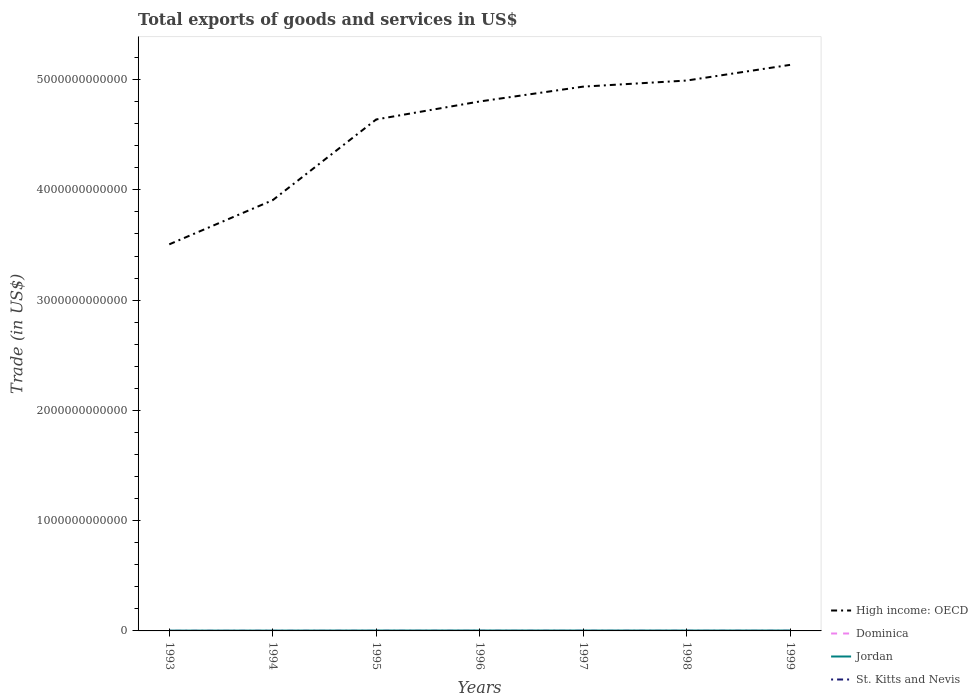Is the number of lines equal to the number of legend labels?
Your answer should be compact. Yes. Across all years, what is the maximum total exports of goods and services in Dominica?
Your answer should be compact. 9.73e+07. What is the total total exports of goods and services in High income: OECD in the graph?
Provide a short and direct response. -1.49e+12. What is the difference between the highest and the second highest total exports of goods and services in Dominica?
Ensure brevity in your answer.  5.95e+07. How many years are there in the graph?
Give a very brief answer. 7. What is the difference between two consecutive major ticks on the Y-axis?
Offer a terse response. 1.00e+12. How many legend labels are there?
Your answer should be compact. 4. How are the legend labels stacked?
Offer a terse response. Vertical. What is the title of the graph?
Your answer should be compact. Total exports of goods and services in US$. Does "Macao" appear as one of the legend labels in the graph?
Your response must be concise. No. What is the label or title of the Y-axis?
Ensure brevity in your answer.  Trade (in US$). What is the Trade (in US$) of High income: OECD in 1993?
Your answer should be very brief. 3.51e+12. What is the Trade (in US$) in Dominica in 1993?
Provide a short and direct response. 9.73e+07. What is the Trade (in US$) of Jordan in 1993?
Give a very brief answer. 2.82e+09. What is the Trade (in US$) in St. Kitts and Nevis in 1993?
Offer a very short reply. 1.15e+08. What is the Trade (in US$) of High income: OECD in 1994?
Provide a short and direct response. 3.91e+12. What is the Trade (in US$) of Dominica in 1994?
Provide a short and direct response. 1.06e+08. What is the Trade (in US$) of Jordan in 1994?
Make the answer very short. 2.98e+09. What is the Trade (in US$) in St. Kitts and Nevis in 1994?
Provide a succinct answer. 1.21e+08. What is the Trade (in US$) in High income: OECD in 1995?
Your response must be concise. 4.64e+12. What is the Trade (in US$) of Dominica in 1995?
Ensure brevity in your answer.  1.12e+08. What is the Trade (in US$) of Jordan in 1995?
Keep it short and to the point. 3.48e+09. What is the Trade (in US$) in St. Kitts and Nevis in 1995?
Your answer should be very brief. 1.19e+08. What is the Trade (in US$) in High income: OECD in 1996?
Provide a short and direct response. 4.80e+12. What is the Trade (in US$) in Dominica in 1996?
Give a very brief answer. 1.21e+08. What is the Trade (in US$) in Jordan in 1996?
Make the answer very short. 3.66e+09. What is the Trade (in US$) of St. Kitts and Nevis in 1996?
Give a very brief answer. 1.28e+08. What is the Trade (in US$) of High income: OECD in 1997?
Your answer should be very brief. 4.94e+12. What is the Trade (in US$) of Dominica in 1997?
Ensure brevity in your answer.  1.37e+08. What is the Trade (in US$) of Jordan in 1997?
Provide a short and direct response. 3.57e+09. What is the Trade (in US$) of St. Kitts and Nevis in 1997?
Offer a terse response. 1.40e+08. What is the Trade (in US$) in High income: OECD in 1998?
Provide a short and direct response. 4.99e+12. What is the Trade (in US$) of Dominica in 1998?
Your response must be concise. 1.52e+08. What is the Trade (in US$) in Jordan in 1998?
Offer a terse response. 3.55e+09. What is the Trade (in US$) of St. Kitts and Nevis in 1998?
Ensure brevity in your answer.  1.45e+08. What is the Trade (in US$) in High income: OECD in 1999?
Keep it short and to the point. 5.13e+12. What is the Trade (in US$) in Dominica in 1999?
Offer a terse response. 1.57e+08. What is the Trade (in US$) in Jordan in 1999?
Your answer should be compact. 3.53e+09. What is the Trade (in US$) of St. Kitts and Nevis in 1999?
Give a very brief answer. 1.46e+08. Across all years, what is the maximum Trade (in US$) of High income: OECD?
Provide a succinct answer. 5.13e+12. Across all years, what is the maximum Trade (in US$) in Dominica?
Your response must be concise. 1.57e+08. Across all years, what is the maximum Trade (in US$) in Jordan?
Offer a very short reply. 3.66e+09. Across all years, what is the maximum Trade (in US$) in St. Kitts and Nevis?
Offer a very short reply. 1.46e+08. Across all years, what is the minimum Trade (in US$) in High income: OECD?
Make the answer very short. 3.51e+12. Across all years, what is the minimum Trade (in US$) in Dominica?
Keep it short and to the point. 9.73e+07. Across all years, what is the minimum Trade (in US$) in Jordan?
Provide a short and direct response. 2.82e+09. Across all years, what is the minimum Trade (in US$) of St. Kitts and Nevis?
Your answer should be compact. 1.15e+08. What is the total Trade (in US$) of High income: OECD in the graph?
Ensure brevity in your answer.  3.19e+13. What is the total Trade (in US$) in Dominica in the graph?
Keep it short and to the point. 8.82e+08. What is the total Trade (in US$) in Jordan in the graph?
Offer a very short reply. 2.36e+1. What is the total Trade (in US$) in St. Kitts and Nevis in the graph?
Offer a terse response. 9.14e+08. What is the difference between the Trade (in US$) in High income: OECD in 1993 and that in 1994?
Make the answer very short. -4.01e+11. What is the difference between the Trade (in US$) of Dominica in 1993 and that in 1994?
Offer a very short reply. -8.37e+06. What is the difference between the Trade (in US$) in Jordan in 1993 and that in 1994?
Make the answer very short. -1.63e+08. What is the difference between the Trade (in US$) of St. Kitts and Nevis in 1993 and that in 1994?
Offer a terse response. -5.53e+06. What is the difference between the Trade (in US$) in High income: OECD in 1993 and that in 1995?
Your answer should be very brief. -1.13e+12. What is the difference between the Trade (in US$) in Dominica in 1993 and that in 1995?
Provide a succinct answer. -1.43e+07. What is the difference between the Trade (in US$) of Jordan in 1993 and that in 1995?
Ensure brevity in your answer.  -6.58e+08. What is the difference between the Trade (in US$) in St. Kitts and Nevis in 1993 and that in 1995?
Ensure brevity in your answer.  -3.09e+06. What is the difference between the Trade (in US$) of High income: OECD in 1993 and that in 1996?
Give a very brief answer. -1.30e+12. What is the difference between the Trade (in US$) in Dominica in 1993 and that in 1996?
Offer a terse response. -2.41e+07. What is the difference between the Trade (in US$) of Jordan in 1993 and that in 1996?
Your answer should be very brief. -8.41e+08. What is the difference between the Trade (in US$) in St. Kitts and Nevis in 1993 and that in 1996?
Make the answer very short. -1.22e+07. What is the difference between the Trade (in US$) of High income: OECD in 1993 and that in 1997?
Your response must be concise. -1.43e+12. What is the difference between the Trade (in US$) of Dominica in 1993 and that in 1997?
Your answer should be compact. -3.98e+07. What is the difference between the Trade (in US$) in Jordan in 1993 and that in 1997?
Provide a succinct answer. -7.50e+08. What is the difference between the Trade (in US$) of St. Kitts and Nevis in 1993 and that in 1997?
Offer a very short reply. -2.50e+07. What is the difference between the Trade (in US$) of High income: OECD in 1993 and that in 1998?
Give a very brief answer. -1.49e+12. What is the difference between the Trade (in US$) of Dominica in 1993 and that in 1998?
Make the answer very short. -5.43e+07. What is the difference between the Trade (in US$) in Jordan in 1993 and that in 1998?
Provide a short and direct response. -7.26e+08. What is the difference between the Trade (in US$) in St. Kitts and Nevis in 1993 and that in 1998?
Provide a short and direct response. -2.97e+07. What is the difference between the Trade (in US$) in High income: OECD in 1993 and that in 1999?
Offer a terse response. -1.63e+12. What is the difference between the Trade (in US$) in Dominica in 1993 and that in 1999?
Your response must be concise. -5.95e+07. What is the difference between the Trade (in US$) in Jordan in 1993 and that in 1999?
Your answer should be compact. -7.12e+08. What is the difference between the Trade (in US$) of St. Kitts and Nevis in 1993 and that in 1999?
Offer a terse response. -3.07e+07. What is the difference between the Trade (in US$) of High income: OECD in 1994 and that in 1995?
Provide a succinct answer. -7.32e+11. What is the difference between the Trade (in US$) of Dominica in 1994 and that in 1995?
Provide a succinct answer. -5.90e+06. What is the difference between the Trade (in US$) of Jordan in 1994 and that in 1995?
Your response must be concise. -4.95e+08. What is the difference between the Trade (in US$) in St. Kitts and Nevis in 1994 and that in 1995?
Your answer should be compact. 2.44e+06. What is the difference between the Trade (in US$) of High income: OECD in 1994 and that in 1996?
Ensure brevity in your answer.  -8.95e+11. What is the difference between the Trade (in US$) in Dominica in 1994 and that in 1996?
Your response must be concise. -1.57e+07. What is the difference between the Trade (in US$) in Jordan in 1994 and that in 1996?
Ensure brevity in your answer.  -6.78e+08. What is the difference between the Trade (in US$) of St. Kitts and Nevis in 1994 and that in 1996?
Make the answer very short. -6.67e+06. What is the difference between the Trade (in US$) of High income: OECD in 1994 and that in 1997?
Give a very brief answer. -1.03e+12. What is the difference between the Trade (in US$) of Dominica in 1994 and that in 1997?
Ensure brevity in your answer.  -3.14e+07. What is the difference between the Trade (in US$) of Jordan in 1994 and that in 1997?
Provide a short and direct response. -5.88e+08. What is the difference between the Trade (in US$) of St. Kitts and Nevis in 1994 and that in 1997?
Offer a very short reply. -1.94e+07. What is the difference between the Trade (in US$) of High income: OECD in 1994 and that in 1998?
Offer a very short reply. -1.08e+12. What is the difference between the Trade (in US$) in Dominica in 1994 and that in 1998?
Offer a terse response. -4.59e+07. What is the difference between the Trade (in US$) of Jordan in 1994 and that in 1998?
Keep it short and to the point. -5.63e+08. What is the difference between the Trade (in US$) of St. Kitts and Nevis in 1994 and that in 1998?
Your answer should be compact. -2.42e+07. What is the difference between the Trade (in US$) in High income: OECD in 1994 and that in 1999?
Offer a terse response. -1.23e+12. What is the difference between the Trade (in US$) of Dominica in 1994 and that in 1999?
Offer a terse response. -5.11e+07. What is the difference between the Trade (in US$) in Jordan in 1994 and that in 1999?
Provide a short and direct response. -5.49e+08. What is the difference between the Trade (in US$) of St. Kitts and Nevis in 1994 and that in 1999?
Provide a short and direct response. -2.52e+07. What is the difference between the Trade (in US$) of High income: OECD in 1995 and that in 1996?
Your response must be concise. -1.63e+11. What is the difference between the Trade (in US$) in Dominica in 1995 and that in 1996?
Your response must be concise. -9.80e+06. What is the difference between the Trade (in US$) of Jordan in 1995 and that in 1996?
Keep it short and to the point. -1.84e+08. What is the difference between the Trade (in US$) in St. Kitts and Nevis in 1995 and that in 1996?
Your answer should be compact. -9.11e+06. What is the difference between the Trade (in US$) in High income: OECD in 1995 and that in 1997?
Make the answer very short. -2.98e+11. What is the difference between the Trade (in US$) in Dominica in 1995 and that in 1997?
Your answer should be compact. -2.55e+07. What is the difference between the Trade (in US$) in Jordan in 1995 and that in 1997?
Your answer should be very brief. -9.28e+07. What is the difference between the Trade (in US$) in St. Kitts and Nevis in 1995 and that in 1997?
Your response must be concise. -2.19e+07. What is the difference between the Trade (in US$) of High income: OECD in 1995 and that in 1998?
Ensure brevity in your answer.  -3.53e+11. What is the difference between the Trade (in US$) of Dominica in 1995 and that in 1998?
Your answer should be very brief. -4.00e+07. What is the difference between the Trade (in US$) in Jordan in 1995 and that in 1998?
Keep it short and to the point. -6.86e+07. What is the difference between the Trade (in US$) in St. Kitts and Nevis in 1995 and that in 1998?
Offer a very short reply. -2.66e+07. What is the difference between the Trade (in US$) of High income: OECD in 1995 and that in 1999?
Provide a short and direct response. -4.95e+11. What is the difference between the Trade (in US$) of Dominica in 1995 and that in 1999?
Your answer should be very brief. -4.52e+07. What is the difference between the Trade (in US$) of Jordan in 1995 and that in 1999?
Your answer should be very brief. -5.41e+07. What is the difference between the Trade (in US$) of St. Kitts and Nevis in 1995 and that in 1999?
Give a very brief answer. -2.77e+07. What is the difference between the Trade (in US$) of High income: OECD in 1996 and that in 1997?
Offer a very short reply. -1.35e+11. What is the difference between the Trade (in US$) in Dominica in 1996 and that in 1997?
Offer a terse response. -1.57e+07. What is the difference between the Trade (in US$) of Jordan in 1996 and that in 1997?
Make the answer very short. 9.08e+07. What is the difference between the Trade (in US$) of St. Kitts and Nevis in 1996 and that in 1997?
Provide a succinct answer. -1.28e+07. What is the difference between the Trade (in US$) in High income: OECD in 1996 and that in 1998?
Provide a short and direct response. -1.90e+11. What is the difference between the Trade (in US$) in Dominica in 1996 and that in 1998?
Provide a succinct answer. -3.02e+07. What is the difference between the Trade (in US$) in Jordan in 1996 and that in 1998?
Provide a short and direct response. 1.15e+08. What is the difference between the Trade (in US$) in St. Kitts and Nevis in 1996 and that in 1998?
Offer a terse response. -1.75e+07. What is the difference between the Trade (in US$) in High income: OECD in 1996 and that in 1999?
Keep it short and to the point. -3.32e+11. What is the difference between the Trade (in US$) in Dominica in 1996 and that in 1999?
Offer a terse response. -3.54e+07. What is the difference between the Trade (in US$) of Jordan in 1996 and that in 1999?
Your answer should be very brief. 1.29e+08. What is the difference between the Trade (in US$) in St. Kitts and Nevis in 1996 and that in 1999?
Ensure brevity in your answer.  -1.85e+07. What is the difference between the Trade (in US$) in High income: OECD in 1997 and that in 1998?
Your answer should be compact. -5.52e+1. What is the difference between the Trade (in US$) of Dominica in 1997 and that in 1998?
Offer a terse response. -1.45e+07. What is the difference between the Trade (in US$) of Jordan in 1997 and that in 1998?
Your answer should be very brief. 2.41e+07. What is the difference between the Trade (in US$) of St. Kitts and Nevis in 1997 and that in 1998?
Give a very brief answer. -4.75e+06. What is the difference between the Trade (in US$) of High income: OECD in 1997 and that in 1999?
Provide a short and direct response. -1.97e+11. What is the difference between the Trade (in US$) of Dominica in 1997 and that in 1999?
Provide a short and direct response. -1.97e+07. What is the difference between the Trade (in US$) in Jordan in 1997 and that in 1999?
Offer a very short reply. 3.86e+07. What is the difference between the Trade (in US$) in St. Kitts and Nevis in 1997 and that in 1999?
Ensure brevity in your answer.  -5.78e+06. What is the difference between the Trade (in US$) in High income: OECD in 1998 and that in 1999?
Offer a terse response. -1.42e+11. What is the difference between the Trade (in US$) in Dominica in 1998 and that in 1999?
Offer a terse response. -5.21e+06. What is the difference between the Trade (in US$) of Jordan in 1998 and that in 1999?
Make the answer very short. 1.45e+07. What is the difference between the Trade (in US$) of St. Kitts and Nevis in 1998 and that in 1999?
Provide a succinct answer. -1.04e+06. What is the difference between the Trade (in US$) of High income: OECD in 1993 and the Trade (in US$) of Dominica in 1994?
Your response must be concise. 3.51e+12. What is the difference between the Trade (in US$) in High income: OECD in 1993 and the Trade (in US$) in Jordan in 1994?
Make the answer very short. 3.50e+12. What is the difference between the Trade (in US$) of High income: OECD in 1993 and the Trade (in US$) of St. Kitts and Nevis in 1994?
Offer a very short reply. 3.51e+12. What is the difference between the Trade (in US$) of Dominica in 1993 and the Trade (in US$) of Jordan in 1994?
Your answer should be very brief. -2.89e+09. What is the difference between the Trade (in US$) in Dominica in 1993 and the Trade (in US$) in St. Kitts and Nevis in 1994?
Make the answer very short. -2.36e+07. What is the difference between the Trade (in US$) in Jordan in 1993 and the Trade (in US$) in St. Kitts and Nevis in 1994?
Offer a terse response. 2.70e+09. What is the difference between the Trade (in US$) of High income: OECD in 1993 and the Trade (in US$) of Dominica in 1995?
Your answer should be very brief. 3.51e+12. What is the difference between the Trade (in US$) in High income: OECD in 1993 and the Trade (in US$) in Jordan in 1995?
Provide a short and direct response. 3.50e+12. What is the difference between the Trade (in US$) in High income: OECD in 1993 and the Trade (in US$) in St. Kitts and Nevis in 1995?
Give a very brief answer. 3.51e+12. What is the difference between the Trade (in US$) in Dominica in 1993 and the Trade (in US$) in Jordan in 1995?
Your answer should be very brief. -3.38e+09. What is the difference between the Trade (in US$) of Dominica in 1993 and the Trade (in US$) of St. Kitts and Nevis in 1995?
Ensure brevity in your answer.  -2.12e+07. What is the difference between the Trade (in US$) of Jordan in 1993 and the Trade (in US$) of St. Kitts and Nevis in 1995?
Make the answer very short. 2.70e+09. What is the difference between the Trade (in US$) in High income: OECD in 1993 and the Trade (in US$) in Dominica in 1996?
Offer a very short reply. 3.51e+12. What is the difference between the Trade (in US$) of High income: OECD in 1993 and the Trade (in US$) of Jordan in 1996?
Provide a succinct answer. 3.50e+12. What is the difference between the Trade (in US$) of High income: OECD in 1993 and the Trade (in US$) of St. Kitts and Nevis in 1996?
Offer a terse response. 3.51e+12. What is the difference between the Trade (in US$) in Dominica in 1993 and the Trade (in US$) in Jordan in 1996?
Offer a very short reply. -3.57e+09. What is the difference between the Trade (in US$) of Dominica in 1993 and the Trade (in US$) of St. Kitts and Nevis in 1996?
Keep it short and to the point. -3.03e+07. What is the difference between the Trade (in US$) of Jordan in 1993 and the Trade (in US$) of St. Kitts and Nevis in 1996?
Provide a short and direct response. 2.69e+09. What is the difference between the Trade (in US$) of High income: OECD in 1993 and the Trade (in US$) of Dominica in 1997?
Your response must be concise. 3.51e+12. What is the difference between the Trade (in US$) of High income: OECD in 1993 and the Trade (in US$) of Jordan in 1997?
Make the answer very short. 3.50e+12. What is the difference between the Trade (in US$) of High income: OECD in 1993 and the Trade (in US$) of St. Kitts and Nevis in 1997?
Offer a very short reply. 3.51e+12. What is the difference between the Trade (in US$) of Dominica in 1993 and the Trade (in US$) of Jordan in 1997?
Offer a terse response. -3.48e+09. What is the difference between the Trade (in US$) in Dominica in 1993 and the Trade (in US$) in St. Kitts and Nevis in 1997?
Provide a succinct answer. -4.31e+07. What is the difference between the Trade (in US$) in Jordan in 1993 and the Trade (in US$) in St. Kitts and Nevis in 1997?
Your response must be concise. 2.68e+09. What is the difference between the Trade (in US$) in High income: OECD in 1993 and the Trade (in US$) in Dominica in 1998?
Your answer should be very brief. 3.51e+12. What is the difference between the Trade (in US$) of High income: OECD in 1993 and the Trade (in US$) of Jordan in 1998?
Make the answer very short. 3.50e+12. What is the difference between the Trade (in US$) in High income: OECD in 1993 and the Trade (in US$) in St. Kitts and Nevis in 1998?
Provide a succinct answer. 3.51e+12. What is the difference between the Trade (in US$) of Dominica in 1993 and the Trade (in US$) of Jordan in 1998?
Keep it short and to the point. -3.45e+09. What is the difference between the Trade (in US$) of Dominica in 1993 and the Trade (in US$) of St. Kitts and Nevis in 1998?
Your answer should be very brief. -4.78e+07. What is the difference between the Trade (in US$) of Jordan in 1993 and the Trade (in US$) of St. Kitts and Nevis in 1998?
Your response must be concise. 2.68e+09. What is the difference between the Trade (in US$) in High income: OECD in 1993 and the Trade (in US$) in Dominica in 1999?
Your answer should be very brief. 3.51e+12. What is the difference between the Trade (in US$) of High income: OECD in 1993 and the Trade (in US$) of Jordan in 1999?
Offer a terse response. 3.50e+12. What is the difference between the Trade (in US$) in High income: OECD in 1993 and the Trade (in US$) in St. Kitts and Nevis in 1999?
Give a very brief answer. 3.51e+12. What is the difference between the Trade (in US$) of Dominica in 1993 and the Trade (in US$) of Jordan in 1999?
Make the answer very short. -3.44e+09. What is the difference between the Trade (in US$) in Dominica in 1993 and the Trade (in US$) in St. Kitts and Nevis in 1999?
Make the answer very short. -4.88e+07. What is the difference between the Trade (in US$) in Jordan in 1993 and the Trade (in US$) in St. Kitts and Nevis in 1999?
Provide a short and direct response. 2.68e+09. What is the difference between the Trade (in US$) in High income: OECD in 1994 and the Trade (in US$) in Dominica in 1995?
Provide a succinct answer. 3.91e+12. What is the difference between the Trade (in US$) of High income: OECD in 1994 and the Trade (in US$) of Jordan in 1995?
Offer a very short reply. 3.90e+12. What is the difference between the Trade (in US$) in High income: OECD in 1994 and the Trade (in US$) in St. Kitts and Nevis in 1995?
Offer a very short reply. 3.91e+12. What is the difference between the Trade (in US$) of Dominica in 1994 and the Trade (in US$) of Jordan in 1995?
Make the answer very short. -3.37e+09. What is the difference between the Trade (in US$) in Dominica in 1994 and the Trade (in US$) in St. Kitts and Nevis in 1995?
Provide a succinct answer. -1.28e+07. What is the difference between the Trade (in US$) of Jordan in 1994 and the Trade (in US$) of St. Kitts and Nevis in 1995?
Keep it short and to the point. 2.87e+09. What is the difference between the Trade (in US$) in High income: OECD in 1994 and the Trade (in US$) in Dominica in 1996?
Your answer should be very brief. 3.91e+12. What is the difference between the Trade (in US$) in High income: OECD in 1994 and the Trade (in US$) in Jordan in 1996?
Offer a very short reply. 3.90e+12. What is the difference between the Trade (in US$) of High income: OECD in 1994 and the Trade (in US$) of St. Kitts and Nevis in 1996?
Provide a succinct answer. 3.91e+12. What is the difference between the Trade (in US$) of Dominica in 1994 and the Trade (in US$) of Jordan in 1996?
Your answer should be compact. -3.56e+09. What is the difference between the Trade (in US$) of Dominica in 1994 and the Trade (in US$) of St. Kitts and Nevis in 1996?
Ensure brevity in your answer.  -2.19e+07. What is the difference between the Trade (in US$) of Jordan in 1994 and the Trade (in US$) of St. Kitts and Nevis in 1996?
Keep it short and to the point. 2.86e+09. What is the difference between the Trade (in US$) of High income: OECD in 1994 and the Trade (in US$) of Dominica in 1997?
Provide a succinct answer. 3.91e+12. What is the difference between the Trade (in US$) of High income: OECD in 1994 and the Trade (in US$) of Jordan in 1997?
Make the answer very short. 3.90e+12. What is the difference between the Trade (in US$) in High income: OECD in 1994 and the Trade (in US$) in St. Kitts and Nevis in 1997?
Give a very brief answer. 3.91e+12. What is the difference between the Trade (in US$) in Dominica in 1994 and the Trade (in US$) in Jordan in 1997?
Your answer should be very brief. -3.47e+09. What is the difference between the Trade (in US$) of Dominica in 1994 and the Trade (in US$) of St. Kitts and Nevis in 1997?
Your answer should be compact. -3.47e+07. What is the difference between the Trade (in US$) in Jordan in 1994 and the Trade (in US$) in St. Kitts and Nevis in 1997?
Ensure brevity in your answer.  2.84e+09. What is the difference between the Trade (in US$) of High income: OECD in 1994 and the Trade (in US$) of Dominica in 1998?
Provide a succinct answer. 3.91e+12. What is the difference between the Trade (in US$) of High income: OECD in 1994 and the Trade (in US$) of Jordan in 1998?
Provide a short and direct response. 3.90e+12. What is the difference between the Trade (in US$) in High income: OECD in 1994 and the Trade (in US$) in St. Kitts and Nevis in 1998?
Provide a short and direct response. 3.91e+12. What is the difference between the Trade (in US$) in Dominica in 1994 and the Trade (in US$) in Jordan in 1998?
Ensure brevity in your answer.  -3.44e+09. What is the difference between the Trade (in US$) of Dominica in 1994 and the Trade (in US$) of St. Kitts and Nevis in 1998?
Provide a succinct answer. -3.94e+07. What is the difference between the Trade (in US$) of Jordan in 1994 and the Trade (in US$) of St. Kitts and Nevis in 1998?
Give a very brief answer. 2.84e+09. What is the difference between the Trade (in US$) of High income: OECD in 1994 and the Trade (in US$) of Dominica in 1999?
Your answer should be compact. 3.91e+12. What is the difference between the Trade (in US$) in High income: OECD in 1994 and the Trade (in US$) in Jordan in 1999?
Give a very brief answer. 3.90e+12. What is the difference between the Trade (in US$) of High income: OECD in 1994 and the Trade (in US$) of St. Kitts and Nevis in 1999?
Offer a very short reply. 3.91e+12. What is the difference between the Trade (in US$) in Dominica in 1994 and the Trade (in US$) in Jordan in 1999?
Give a very brief answer. -3.43e+09. What is the difference between the Trade (in US$) in Dominica in 1994 and the Trade (in US$) in St. Kitts and Nevis in 1999?
Keep it short and to the point. -4.05e+07. What is the difference between the Trade (in US$) of Jordan in 1994 and the Trade (in US$) of St. Kitts and Nevis in 1999?
Your answer should be compact. 2.84e+09. What is the difference between the Trade (in US$) in High income: OECD in 1995 and the Trade (in US$) in Dominica in 1996?
Offer a very short reply. 4.64e+12. What is the difference between the Trade (in US$) of High income: OECD in 1995 and the Trade (in US$) of Jordan in 1996?
Give a very brief answer. 4.64e+12. What is the difference between the Trade (in US$) in High income: OECD in 1995 and the Trade (in US$) in St. Kitts and Nevis in 1996?
Offer a terse response. 4.64e+12. What is the difference between the Trade (in US$) of Dominica in 1995 and the Trade (in US$) of Jordan in 1996?
Offer a very short reply. -3.55e+09. What is the difference between the Trade (in US$) in Dominica in 1995 and the Trade (in US$) in St. Kitts and Nevis in 1996?
Your answer should be very brief. -1.60e+07. What is the difference between the Trade (in US$) in Jordan in 1995 and the Trade (in US$) in St. Kitts and Nevis in 1996?
Make the answer very short. 3.35e+09. What is the difference between the Trade (in US$) of High income: OECD in 1995 and the Trade (in US$) of Dominica in 1997?
Give a very brief answer. 4.64e+12. What is the difference between the Trade (in US$) of High income: OECD in 1995 and the Trade (in US$) of Jordan in 1997?
Keep it short and to the point. 4.64e+12. What is the difference between the Trade (in US$) in High income: OECD in 1995 and the Trade (in US$) in St. Kitts and Nevis in 1997?
Give a very brief answer. 4.64e+12. What is the difference between the Trade (in US$) of Dominica in 1995 and the Trade (in US$) of Jordan in 1997?
Give a very brief answer. -3.46e+09. What is the difference between the Trade (in US$) in Dominica in 1995 and the Trade (in US$) in St. Kitts and Nevis in 1997?
Give a very brief answer. -2.88e+07. What is the difference between the Trade (in US$) in Jordan in 1995 and the Trade (in US$) in St. Kitts and Nevis in 1997?
Offer a terse response. 3.34e+09. What is the difference between the Trade (in US$) of High income: OECD in 1995 and the Trade (in US$) of Dominica in 1998?
Offer a very short reply. 4.64e+12. What is the difference between the Trade (in US$) of High income: OECD in 1995 and the Trade (in US$) of Jordan in 1998?
Provide a succinct answer. 4.64e+12. What is the difference between the Trade (in US$) in High income: OECD in 1995 and the Trade (in US$) in St. Kitts and Nevis in 1998?
Offer a terse response. 4.64e+12. What is the difference between the Trade (in US$) in Dominica in 1995 and the Trade (in US$) in Jordan in 1998?
Offer a terse response. -3.44e+09. What is the difference between the Trade (in US$) of Dominica in 1995 and the Trade (in US$) of St. Kitts and Nevis in 1998?
Give a very brief answer. -3.35e+07. What is the difference between the Trade (in US$) of Jordan in 1995 and the Trade (in US$) of St. Kitts and Nevis in 1998?
Your answer should be very brief. 3.33e+09. What is the difference between the Trade (in US$) in High income: OECD in 1995 and the Trade (in US$) in Dominica in 1999?
Offer a terse response. 4.64e+12. What is the difference between the Trade (in US$) of High income: OECD in 1995 and the Trade (in US$) of Jordan in 1999?
Keep it short and to the point. 4.64e+12. What is the difference between the Trade (in US$) in High income: OECD in 1995 and the Trade (in US$) in St. Kitts and Nevis in 1999?
Make the answer very short. 4.64e+12. What is the difference between the Trade (in US$) of Dominica in 1995 and the Trade (in US$) of Jordan in 1999?
Your answer should be compact. -3.42e+09. What is the difference between the Trade (in US$) of Dominica in 1995 and the Trade (in US$) of St. Kitts and Nevis in 1999?
Keep it short and to the point. -3.46e+07. What is the difference between the Trade (in US$) of Jordan in 1995 and the Trade (in US$) of St. Kitts and Nevis in 1999?
Provide a short and direct response. 3.33e+09. What is the difference between the Trade (in US$) of High income: OECD in 1996 and the Trade (in US$) of Dominica in 1997?
Your answer should be compact. 4.80e+12. What is the difference between the Trade (in US$) in High income: OECD in 1996 and the Trade (in US$) in Jordan in 1997?
Keep it short and to the point. 4.80e+12. What is the difference between the Trade (in US$) in High income: OECD in 1996 and the Trade (in US$) in St. Kitts and Nevis in 1997?
Your answer should be very brief. 4.80e+12. What is the difference between the Trade (in US$) in Dominica in 1996 and the Trade (in US$) in Jordan in 1997?
Offer a very short reply. -3.45e+09. What is the difference between the Trade (in US$) in Dominica in 1996 and the Trade (in US$) in St. Kitts and Nevis in 1997?
Provide a short and direct response. -1.90e+07. What is the difference between the Trade (in US$) in Jordan in 1996 and the Trade (in US$) in St. Kitts and Nevis in 1997?
Your answer should be compact. 3.52e+09. What is the difference between the Trade (in US$) in High income: OECD in 1996 and the Trade (in US$) in Dominica in 1998?
Offer a terse response. 4.80e+12. What is the difference between the Trade (in US$) in High income: OECD in 1996 and the Trade (in US$) in Jordan in 1998?
Keep it short and to the point. 4.80e+12. What is the difference between the Trade (in US$) in High income: OECD in 1996 and the Trade (in US$) in St. Kitts and Nevis in 1998?
Ensure brevity in your answer.  4.80e+12. What is the difference between the Trade (in US$) in Dominica in 1996 and the Trade (in US$) in Jordan in 1998?
Provide a succinct answer. -3.43e+09. What is the difference between the Trade (in US$) in Dominica in 1996 and the Trade (in US$) in St. Kitts and Nevis in 1998?
Ensure brevity in your answer.  -2.37e+07. What is the difference between the Trade (in US$) in Jordan in 1996 and the Trade (in US$) in St. Kitts and Nevis in 1998?
Your response must be concise. 3.52e+09. What is the difference between the Trade (in US$) in High income: OECD in 1996 and the Trade (in US$) in Dominica in 1999?
Your answer should be very brief. 4.80e+12. What is the difference between the Trade (in US$) of High income: OECD in 1996 and the Trade (in US$) of Jordan in 1999?
Offer a terse response. 4.80e+12. What is the difference between the Trade (in US$) in High income: OECD in 1996 and the Trade (in US$) in St. Kitts and Nevis in 1999?
Keep it short and to the point. 4.80e+12. What is the difference between the Trade (in US$) of Dominica in 1996 and the Trade (in US$) of Jordan in 1999?
Offer a very short reply. -3.41e+09. What is the difference between the Trade (in US$) of Dominica in 1996 and the Trade (in US$) of St. Kitts and Nevis in 1999?
Your response must be concise. -2.48e+07. What is the difference between the Trade (in US$) in Jordan in 1996 and the Trade (in US$) in St. Kitts and Nevis in 1999?
Make the answer very short. 3.52e+09. What is the difference between the Trade (in US$) in High income: OECD in 1997 and the Trade (in US$) in Dominica in 1998?
Offer a terse response. 4.94e+12. What is the difference between the Trade (in US$) of High income: OECD in 1997 and the Trade (in US$) of Jordan in 1998?
Ensure brevity in your answer.  4.93e+12. What is the difference between the Trade (in US$) in High income: OECD in 1997 and the Trade (in US$) in St. Kitts and Nevis in 1998?
Your answer should be compact. 4.94e+12. What is the difference between the Trade (in US$) in Dominica in 1997 and the Trade (in US$) in Jordan in 1998?
Keep it short and to the point. -3.41e+09. What is the difference between the Trade (in US$) of Dominica in 1997 and the Trade (in US$) of St. Kitts and Nevis in 1998?
Ensure brevity in your answer.  -7.98e+06. What is the difference between the Trade (in US$) in Jordan in 1997 and the Trade (in US$) in St. Kitts and Nevis in 1998?
Give a very brief answer. 3.43e+09. What is the difference between the Trade (in US$) in High income: OECD in 1997 and the Trade (in US$) in Dominica in 1999?
Your answer should be very brief. 4.94e+12. What is the difference between the Trade (in US$) in High income: OECD in 1997 and the Trade (in US$) in Jordan in 1999?
Keep it short and to the point. 4.93e+12. What is the difference between the Trade (in US$) in High income: OECD in 1997 and the Trade (in US$) in St. Kitts and Nevis in 1999?
Ensure brevity in your answer.  4.94e+12. What is the difference between the Trade (in US$) of Dominica in 1997 and the Trade (in US$) of Jordan in 1999?
Provide a succinct answer. -3.40e+09. What is the difference between the Trade (in US$) of Dominica in 1997 and the Trade (in US$) of St. Kitts and Nevis in 1999?
Keep it short and to the point. -9.02e+06. What is the difference between the Trade (in US$) of Jordan in 1997 and the Trade (in US$) of St. Kitts and Nevis in 1999?
Provide a short and direct response. 3.43e+09. What is the difference between the Trade (in US$) in High income: OECD in 1998 and the Trade (in US$) in Dominica in 1999?
Ensure brevity in your answer.  4.99e+12. What is the difference between the Trade (in US$) in High income: OECD in 1998 and the Trade (in US$) in Jordan in 1999?
Your answer should be very brief. 4.99e+12. What is the difference between the Trade (in US$) in High income: OECD in 1998 and the Trade (in US$) in St. Kitts and Nevis in 1999?
Provide a succinct answer. 4.99e+12. What is the difference between the Trade (in US$) in Dominica in 1998 and the Trade (in US$) in Jordan in 1999?
Keep it short and to the point. -3.38e+09. What is the difference between the Trade (in US$) in Dominica in 1998 and the Trade (in US$) in St. Kitts and Nevis in 1999?
Ensure brevity in your answer.  5.44e+06. What is the difference between the Trade (in US$) in Jordan in 1998 and the Trade (in US$) in St. Kitts and Nevis in 1999?
Your answer should be very brief. 3.40e+09. What is the average Trade (in US$) of High income: OECD per year?
Make the answer very short. 4.56e+12. What is the average Trade (in US$) of Dominica per year?
Offer a terse response. 1.26e+08. What is the average Trade (in US$) in Jordan per year?
Give a very brief answer. 3.37e+09. What is the average Trade (in US$) in St. Kitts and Nevis per year?
Offer a very short reply. 1.31e+08. In the year 1993, what is the difference between the Trade (in US$) of High income: OECD and Trade (in US$) of Dominica?
Give a very brief answer. 3.51e+12. In the year 1993, what is the difference between the Trade (in US$) of High income: OECD and Trade (in US$) of Jordan?
Keep it short and to the point. 3.50e+12. In the year 1993, what is the difference between the Trade (in US$) in High income: OECD and Trade (in US$) in St. Kitts and Nevis?
Provide a succinct answer. 3.51e+12. In the year 1993, what is the difference between the Trade (in US$) of Dominica and Trade (in US$) of Jordan?
Give a very brief answer. -2.72e+09. In the year 1993, what is the difference between the Trade (in US$) in Dominica and Trade (in US$) in St. Kitts and Nevis?
Make the answer very short. -1.81e+07. In the year 1993, what is the difference between the Trade (in US$) of Jordan and Trade (in US$) of St. Kitts and Nevis?
Make the answer very short. 2.71e+09. In the year 1994, what is the difference between the Trade (in US$) in High income: OECD and Trade (in US$) in Dominica?
Your response must be concise. 3.91e+12. In the year 1994, what is the difference between the Trade (in US$) of High income: OECD and Trade (in US$) of Jordan?
Offer a terse response. 3.90e+12. In the year 1994, what is the difference between the Trade (in US$) of High income: OECD and Trade (in US$) of St. Kitts and Nevis?
Offer a very short reply. 3.91e+12. In the year 1994, what is the difference between the Trade (in US$) of Dominica and Trade (in US$) of Jordan?
Provide a short and direct response. -2.88e+09. In the year 1994, what is the difference between the Trade (in US$) of Dominica and Trade (in US$) of St. Kitts and Nevis?
Your response must be concise. -1.52e+07. In the year 1994, what is the difference between the Trade (in US$) of Jordan and Trade (in US$) of St. Kitts and Nevis?
Your answer should be compact. 2.86e+09. In the year 1995, what is the difference between the Trade (in US$) in High income: OECD and Trade (in US$) in Dominica?
Keep it short and to the point. 4.64e+12. In the year 1995, what is the difference between the Trade (in US$) of High income: OECD and Trade (in US$) of Jordan?
Your answer should be very brief. 4.64e+12. In the year 1995, what is the difference between the Trade (in US$) of High income: OECD and Trade (in US$) of St. Kitts and Nevis?
Keep it short and to the point. 4.64e+12. In the year 1995, what is the difference between the Trade (in US$) in Dominica and Trade (in US$) in Jordan?
Provide a short and direct response. -3.37e+09. In the year 1995, what is the difference between the Trade (in US$) of Dominica and Trade (in US$) of St. Kitts and Nevis?
Give a very brief answer. -6.91e+06. In the year 1995, what is the difference between the Trade (in US$) of Jordan and Trade (in US$) of St. Kitts and Nevis?
Offer a very short reply. 3.36e+09. In the year 1996, what is the difference between the Trade (in US$) of High income: OECD and Trade (in US$) of Dominica?
Offer a very short reply. 4.80e+12. In the year 1996, what is the difference between the Trade (in US$) of High income: OECD and Trade (in US$) of Jordan?
Provide a short and direct response. 4.80e+12. In the year 1996, what is the difference between the Trade (in US$) in High income: OECD and Trade (in US$) in St. Kitts and Nevis?
Offer a terse response. 4.80e+12. In the year 1996, what is the difference between the Trade (in US$) in Dominica and Trade (in US$) in Jordan?
Your answer should be compact. -3.54e+09. In the year 1996, what is the difference between the Trade (in US$) in Dominica and Trade (in US$) in St. Kitts and Nevis?
Keep it short and to the point. -6.22e+06. In the year 1996, what is the difference between the Trade (in US$) in Jordan and Trade (in US$) in St. Kitts and Nevis?
Provide a succinct answer. 3.54e+09. In the year 1997, what is the difference between the Trade (in US$) of High income: OECD and Trade (in US$) of Dominica?
Provide a succinct answer. 4.94e+12. In the year 1997, what is the difference between the Trade (in US$) in High income: OECD and Trade (in US$) in Jordan?
Give a very brief answer. 4.93e+12. In the year 1997, what is the difference between the Trade (in US$) of High income: OECD and Trade (in US$) of St. Kitts and Nevis?
Make the answer very short. 4.94e+12. In the year 1997, what is the difference between the Trade (in US$) of Dominica and Trade (in US$) of Jordan?
Ensure brevity in your answer.  -3.44e+09. In the year 1997, what is the difference between the Trade (in US$) in Dominica and Trade (in US$) in St. Kitts and Nevis?
Give a very brief answer. -3.23e+06. In the year 1997, what is the difference between the Trade (in US$) of Jordan and Trade (in US$) of St. Kitts and Nevis?
Keep it short and to the point. 3.43e+09. In the year 1998, what is the difference between the Trade (in US$) in High income: OECD and Trade (in US$) in Dominica?
Ensure brevity in your answer.  4.99e+12. In the year 1998, what is the difference between the Trade (in US$) of High income: OECD and Trade (in US$) of Jordan?
Your response must be concise. 4.99e+12. In the year 1998, what is the difference between the Trade (in US$) in High income: OECD and Trade (in US$) in St. Kitts and Nevis?
Ensure brevity in your answer.  4.99e+12. In the year 1998, what is the difference between the Trade (in US$) of Dominica and Trade (in US$) of Jordan?
Make the answer very short. -3.40e+09. In the year 1998, what is the difference between the Trade (in US$) of Dominica and Trade (in US$) of St. Kitts and Nevis?
Ensure brevity in your answer.  6.48e+06. In the year 1998, what is the difference between the Trade (in US$) in Jordan and Trade (in US$) in St. Kitts and Nevis?
Provide a short and direct response. 3.40e+09. In the year 1999, what is the difference between the Trade (in US$) of High income: OECD and Trade (in US$) of Dominica?
Make the answer very short. 5.13e+12. In the year 1999, what is the difference between the Trade (in US$) in High income: OECD and Trade (in US$) in Jordan?
Offer a very short reply. 5.13e+12. In the year 1999, what is the difference between the Trade (in US$) in High income: OECD and Trade (in US$) in St. Kitts and Nevis?
Your answer should be compact. 5.13e+12. In the year 1999, what is the difference between the Trade (in US$) of Dominica and Trade (in US$) of Jordan?
Provide a short and direct response. -3.38e+09. In the year 1999, what is the difference between the Trade (in US$) in Dominica and Trade (in US$) in St. Kitts and Nevis?
Provide a succinct answer. 1.07e+07. In the year 1999, what is the difference between the Trade (in US$) of Jordan and Trade (in US$) of St. Kitts and Nevis?
Keep it short and to the point. 3.39e+09. What is the ratio of the Trade (in US$) of High income: OECD in 1993 to that in 1994?
Give a very brief answer. 0.9. What is the ratio of the Trade (in US$) of Dominica in 1993 to that in 1994?
Ensure brevity in your answer.  0.92. What is the ratio of the Trade (in US$) of Jordan in 1993 to that in 1994?
Give a very brief answer. 0.95. What is the ratio of the Trade (in US$) in St. Kitts and Nevis in 1993 to that in 1994?
Make the answer very short. 0.95. What is the ratio of the Trade (in US$) of High income: OECD in 1993 to that in 1995?
Your response must be concise. 0.76. What is the ratio of the Trade (in US$) in Dominica in 1993 to that in 1995?
Provide a succinct answer. 0.87. What is the ratio of the Trade (in US$) of Jordan in 1993 to that in 1995?
Offer a very short reply. 0.81. What is the ratio of the Trade (in US$) in St. Kitts and Nevis in 1993 to that in 1995?
Your answer should be very brief. 0.97. What is the ratio of the Trade (in US$) in High income: OECD in 1993 to that in 1996?
Give a very brief answer. 0.73. What is the ratio of the Trade (in US$) in Dominica in 1993 to that in 1996?
Your answer should be very brief. 0.8. What is the ratio of the Trade (in US$) in Jordan in 1993 to that in 1996?
Your answer should be very brief. 0.77. What is the ratio of the Trade (in US$) of St. Kitts and Nevis in 1993 to that in 1996?
Your answer should be compact. 0.9. What is the ratio of the Trade (in US$) of High income: OECD in 1993 to that in 1997?
Offer a very short reply. 0.71. What is the ratio of the Trade (in US$) in Dominica in 1993 to that in 1997?
Offer a terse response. 0.71. What is the ratio of the Trade (in US$) in Jordan in 1993 to that in 1997?
Your answer should be very brief. 0.79. What is the ratio of the Trade (in US$) in St. Kitts and Nevis in 1993 to that in 1997?
Offer a very short reply. 0.82. What is the ratio of the Trade (in US$) in High income: OECD in 1993 to that in 1998?
Your response must be concise. 0.7. What is the ratio of the Trade (in US$) of Dominica in 1993 to that in 1998?
Keep it short and to the point. 0.64. What is the ratio of the Trade (in US$) of Jordan in 1993 to that in 1998?
Provide a short and direct response. 0.8. What is the ratio of the Trade (in US$) of St. Kitts and Nevis in 1993 to that in 1998?
Provide a succinct answer. 0.8. What is the ratio of the Trade (in US$) of High income: OECD in 1993 to that in 1999?
Keep it short and to the point. 0.68. What is the ratio of the Trade (in US$) in Dominica in 1993 to that in 1999?
Offer a very short reply. 0.62. What is the ratio of the Trade (in US$) in Jordan in 1993 to that in 1999?
Your answer should be very brief. 0.8. What is the ratio of the Trade (in US$) of St. Kitts and Nevis in 1993 to that in 1999?
Give a very brief answer. 0.79. What is the ratio of the Trade (in US$) of High income: OECD in 1994 to that in 1995?
Offer a terse response. 0.84. What is the ratio of the Trade (in US$) in Dominica in 1994 to that in 1995?
Keep it short and to the point. 0.95. What is the ratio of the Trade (in US$) in Jordan in 1994 to that in 1995?
Your answer should be very brief. 0.86. What is the ratio of the Trade (in US$) of St. Kitts and Nevis in 1994 to that in 1995?
Make the answer very short. 1.02. What is the ratio of the Trade (in US$) of High income: OECD in 1994 to that in 1996?
Your answer should be very brief. 0.81. What is the ratio of the Trade (in US$) in Dominica in 1994 to that in 1996?
Your answer should be very brief. 0.87. What is the ratio of the Trade (in US$) of Jordan in 1994 to that in 1996?
Provide a succinct answer. 0.81. What is the ratio of the Trade (in US$) in St. Kitts and Nevis in 1994 to that in 1996?
Provide a succinct answer. 0.95. What is the ratio of the Trade (in US$) of High income: OECD in 1994 to that in 1997?
Offer a very short reply. 0.79. What is the ratio of the Trade (in US$) in Dominica in 1994 to that in 1997?
Your response must be concise. 0.77. What is the ratio of the Trade (in US$) in Jordan in 1994 to that in 1997?
Your response must be concise. 0.84. What is the ratio of the Trade (in US$) of St. Kitts and Nevis in 1994 to that in 1997?
Your answer should be very brief. 0.86. What is the ratio of the Trade (in US$) of High income: OECD in 1994 to that in 1998?
Keep it short and to the point. 0.78. What is the ratio of the Trade (in US$) of Dominica in 1994 to that in 1998?
Provide a succinct answer. 0.7. What is the ratio of the Trade (in US$) in Jordan in 1994 to that in 1998?
Your answer should be very brief. 0.84. What is the ratio of the Trade (in US$) in St. Kitts and Nevis in 1994 to that in 1998?
Keep it short and to the point. 0.83. What is the ratio of the Trade (in US$) of High income: OECD in 1994 to that in 1999?
Make the answer very short. 0.76. What is the ratio of the Trade (in US$) in Dominica in 1994 to that in 1999?
Your answer should be compact. 0.67. What is the ratio of the Trade (in US$) of Jordan in 1994 to that in 1999?
Provide a succinct answer. 0.84. What is the ratio of the Trade (in US$) of St. Kitts and Nevis in 1994 to that in 1999?
Give a very brief answer. 0.83. What is the ratio of the Trade (in US$) of High income: OECD in 1995 to that in 1996?
Keep it short and to the point. 0.97. What is the ratio of the Trade (in US$) in Dominica in 1995 to that in 1996?
Keep it short and to the point. 0.92. What is the ratio of the Trade (in US$) of Jordan in 1995 to that in 1996?
Your response must be concise. 0.95. What is the ratio of the Trade (in US$) in St. Kitts and Nevis in 1995 to that in 1996?
Offer a very short reply. 0.93. What is the ratio of the Trade (in US$) of High income: OECD in 1995 to that in 1997?
Your response must be concise. 0.94. What is the ratio of the Trade (in US$) in Dominica in 1995 to that in 1997?
Keep it short and to the point. 0.81. What is the ratio of the Trade (in US$) in Jordan in 1995 to that in 1997?
Offer a very short reply. 0.97. What is the ratio of the Trade (in US$) of St. Kitts and Nevis in 1995 to that in 1997?
Your answer should be very brief. 0.84. What is the ratio of the Trade (in US$) in High income: OECD in 1995 to that in 1998?
Keep it short and to the point. 0.93. What is the ratio of the Trade (in US$) of Dominica in 1995 to that in 1998?
Ensure brevity in your answer.  0.74. What is the ratio of the Trade (in US$) in Jordan in 1995 to that in 1998?
Offer a terse response. 0.98. What is the ratio of the Trade (in US$) of St. Kitts and Nevis in 1995 to that in 1998?
Ensure brevity in your answer.  0.82. What is the ratio of the Trade (in US$) of High income: OECD in 1995 to that in 1999?
Offer a very short reply. 0.9. What is the ratio of the Trade (in US$) of Dominica in 1995 to that in 1999?
Your response must be concise. 0.71. What is the ratio of the Trade (in US$) of Jordan in 1995 to that in 1999?
Ensure brevity in your answer.  0.98. What is the ratio of the Trade (in US$) of St. Kitts and Nevis in 1995 to that in 1999?
Your response must be concise. 0.81. What is the ratio of the Trade (in US$) in High income: OECD in 1996 to that in 1997?
Your response must be concise. 0.97. What is the ratio of the Trade (in US$) of Dominica in 1996 to that in 1997?
Your answer should be very brief. 0.89. What is the ratio of the Trade (in US$) of Jordan in 1996 to that in 1997?
Offer a very short reply. 1.03. What is the ratio of the Trade (in US$) of Dominica in 1996 to that in 1998?
Make the answer very short. 0.8. What is the ratio of the Trade (in US$) of Jordan in 1996 to that in 1998?
Give a very brief answer. 1.03. What is the ratio of the Trade (in US$) of St. Kitts and Nevis in 1996 to that in 1998?
Keep it short and to the point. 0.88. What is the ratio of the Trade (in US$) in High income: OECD in 1996 to that in 1999?
Your answer should be very brief. 0.94. What is the ratio of the Trade (in US$) in Dominica in 1996 to that in 1999?
Provide a short and direct response. 0.77. What is the ratio of the Trade (in US$) of Jordan in 1996 to that in 1999?
Provide a succinct answer. 1.04. What is the ratio of the Trade (in US$) of St. Kitts and Nevis in 1996 to that in 1999?
Give a very brief answer. 0.87. What is the ratio of the Trade (in US$) of High income: OECD in 1997 to that in 1998?
Offer a very short reply. 0.99. What is the ratio of the Trade (in US$) of Dominica in 1997 to that in 1998?
Offer a terse response. 0.9. What is the ratio of the Trade (in US$) of Jordan in 1997 to that in 1998?
Offer a very short reply. 1.01. What is the ratio of the Trade (in US$) of St. Kitts and Nevis in 1997 to that in 1998?
Keep it short and to the point. 0.97. What is the ratio of the Trade (in US$) of High income: OECD in 1997 to that in 1999?
Offer a very short reply. 0.96. What is the ratio of the Trade (in US$) of Dominica in 1997 to that in 1999?
Your response must be concise. 0.87. What is the ratio of the Trade (in US$) in Jordan in 1997 to that in 1999?
Your answer should be very brief. 1.01. What is the ratio of the Trade (in US$) in St. Kitts and Nevis in 1997 to that in 1999?
Offer a terse response. 0.96. What is the ratio of the Trade (in US$) of High income: OECD in 1998 to that in 1999?
Provide a short and direct response. 0.97. What is the ratio of the Trade (in US$) in Dominica in 1998 to that in 1999?
Make the answer very short. 0.97. What is the ratio of the Trade (in US$) in Jordan in 1998 to that in 1999?
Your answer should be very brief. 1. What is the ratio of the Trade (in US$) in St. Kitts and Nevis in 1998 to that in 1999?
Give a very brief answer. 0.99. What is the difference between the highest and the second highest Trade (in US$) in High income: OECD?
Provide a short and direct response. 1.42e+11. What is the difference between the highest and the second highest Trade (in US$) in Dominica?
Provide a short and direct response. 5.21e+06. What is the difference between the highest and the second highest Trade (in US$) of Jordan?
Keep it short and to the point. 9.08e+07. What is the difference between the highest and the second highest Trade (in US$) of St. Kitts and Nevis?
Your answer should be compact. 1.04e+06. What is the difference between the highest and the lowest Trade (in US$) of High income: OECD?
Your response must be concise. 1.63e+12. What is the difference between the highest and the lowest Trade (in US$) of Dominica?
Ensure brevity in your answer.  5.95e+07. What is the difference between the highest and the lowest Trade (in US$) of Jordan?
Ensure brevity in your answer.  8.41e+08. What is the difference between the highest and the lowest Trade (in US$) in St. Kitts and Nevis?
Your answer should be very brief. 3.07e+07. 